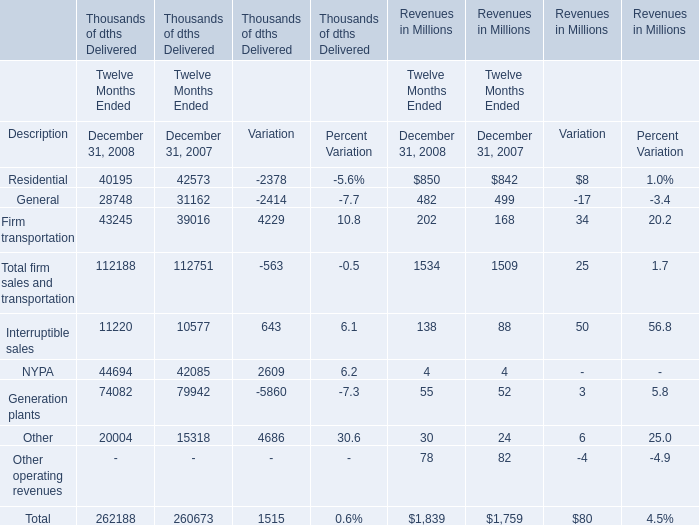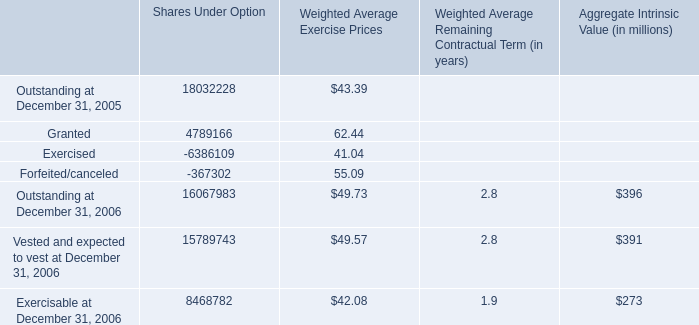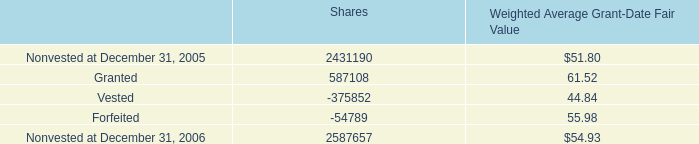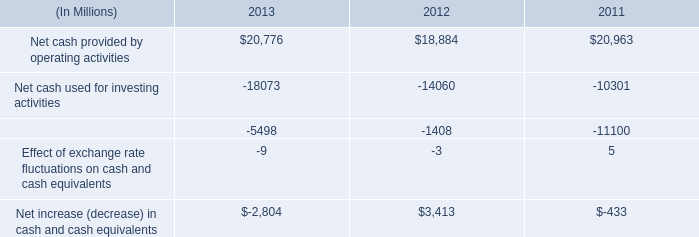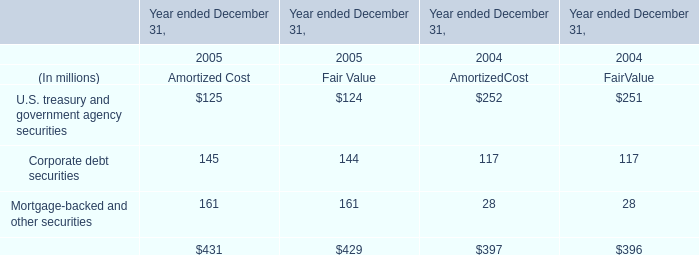what was the percentage change in net cash provided by operating activities between 2012 and 2013? 
Computations: ((20776 - 18884) / 18884)
Answer: 0.10019. 